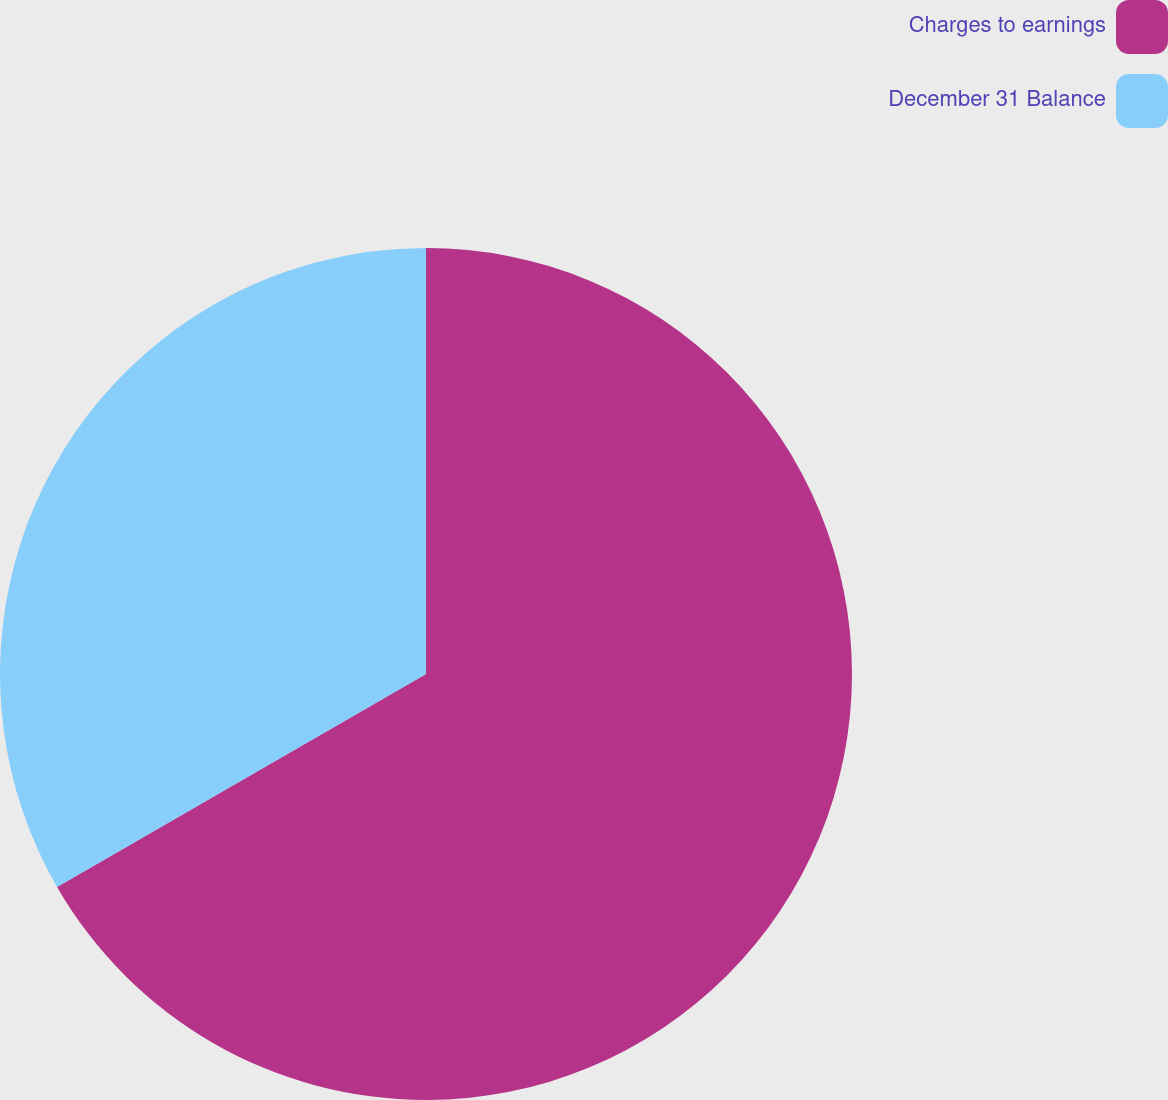<chart> <loc_0><loc_0><loc_500><loc_500><pie_chart><fcel>Charges to earnings<fcel>December 31 Balance<nl><fcel>66.67%<fcel>33.33%<nl></chart> 